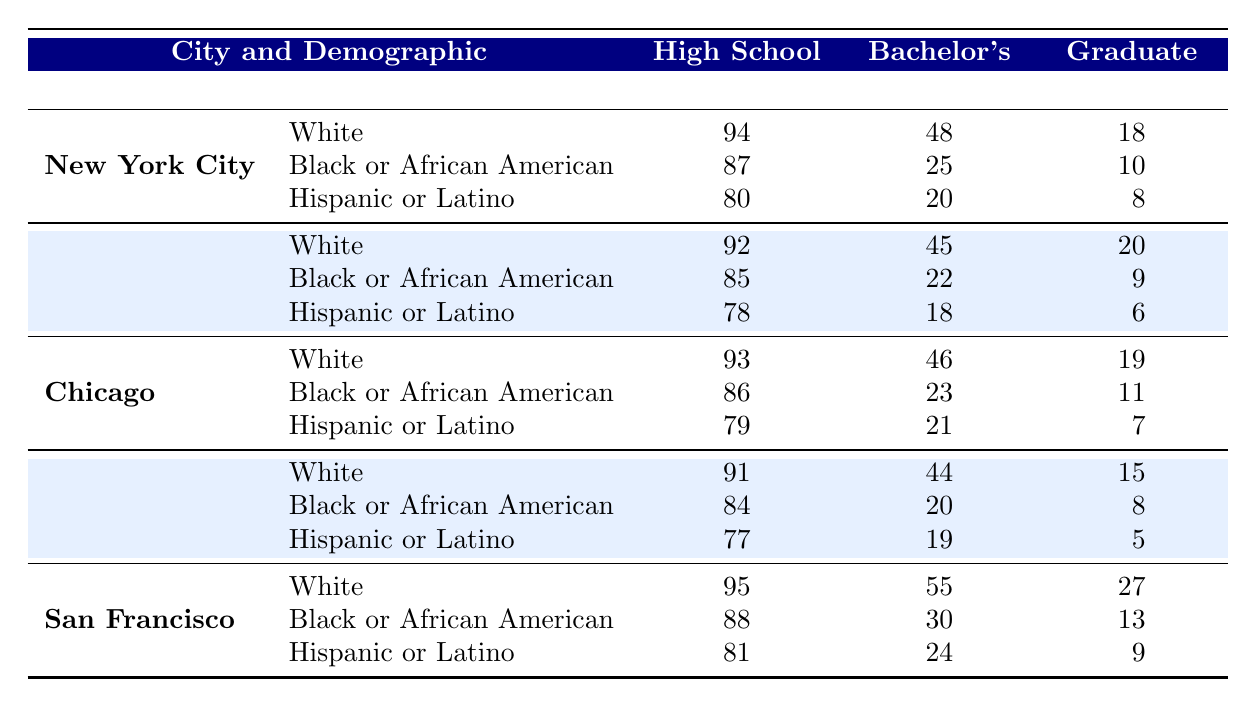What percentage of Hispanic or Latino individuals in San Francisco have a Bachelor's degree? According to the table, the percentage of Hispanic or Latino individuals in San Francisco with a Bachelor's degree is clearly listed as 24%.
Answer: 24% Which demographic in New York City has the highest percentage of High School diploma attainment? By comparing the percentages for High School diploma attainment among White (94%), Black or African American (87%), and Hispanic or Latino (80%) demographics in New York City, White has the highest percentage at 94%.
Answer: 94% What is the difference in Graduate degree attainment between White individuals in San Francisco and those in Chicago? The table shows that White individuals in San Francisco have a Graduate degree attainment of 27%, while those in Chicago have 19%. The difference is calculated as 27% - 19% = 8%.
Answer: 8% Is there a higher percentage of Bachelor's degree holders among Hispanic or Latino individuals in Houston or Los Angeles? The Bachelor's degree percentages for Hispanic or Latino individuals are 19% in Houston and 18% in Los Angeles. Since 19% > 18%, there is a higher percentage in Houston.
Answer: Yes What is the average percentage of High School diploma attainment among all demographics in Chicago? The percentages for High School diploma attainment in Chicago are 93% (White), 86% (Black or African American), and 79% (Hispanic or Latino). The average is calculated as (93 + 86 + 79) / 3 = 252 / 3 = 84%.
Answer: 84% Which city has the highest percentage of Bachelor's degree attainment among Black or African American individuals? In the table, the percentages for Black or African American individuals are 25% (New York City), 22% (Los Angeles), 23% (Chicago), 20% (Houston), and 30% (San Francisco). San Francisco has the highest at 30%.
Answer: 30% If the percentage of Graduate degree holders in Los Angeles is compared to that in Houston among Black or African American individuals, which city has a lower percentage? The table shows that Black or African American individuals in Los Angeles have 9% with a Graduate degree and those in Houston have 8%. Comparing these percentages, Houston has a lower percentage.
Answer: Houston What percentage of White individuals in Los Angeles have at least a Bachelor’s degree? In Los Angeles, the White demographic has 45% with a Bachelor's degree. Adding this to the Graduate degree percentage of 20%, the total for at least a Bachelor's degree is 45% + 20% = 65%.
Answer: 65% 